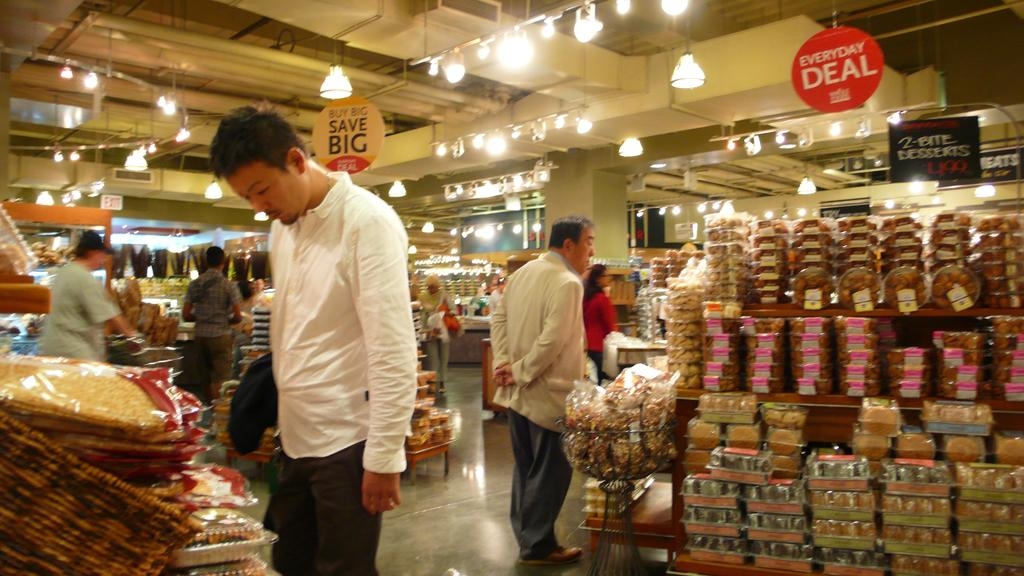<image>
Summarize the visual content of the image. Shoppers looking through the everyday deal sections to save big. 